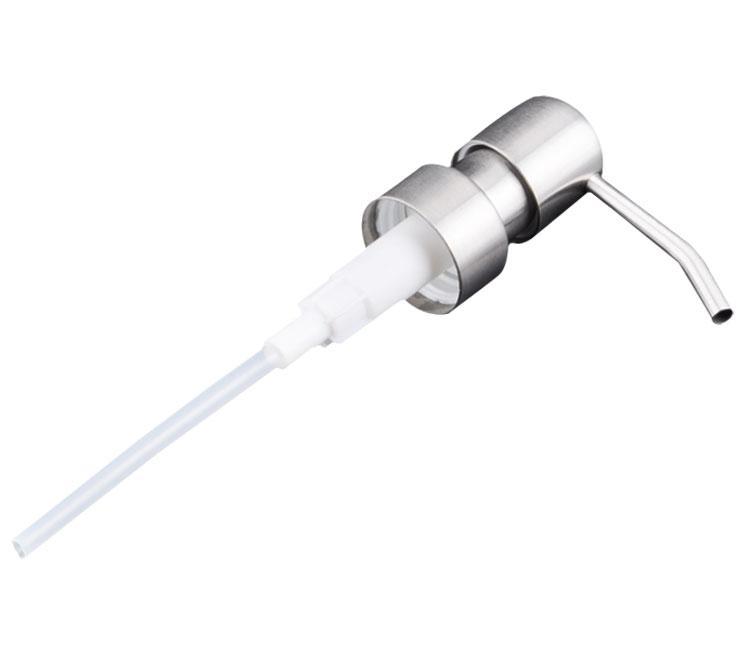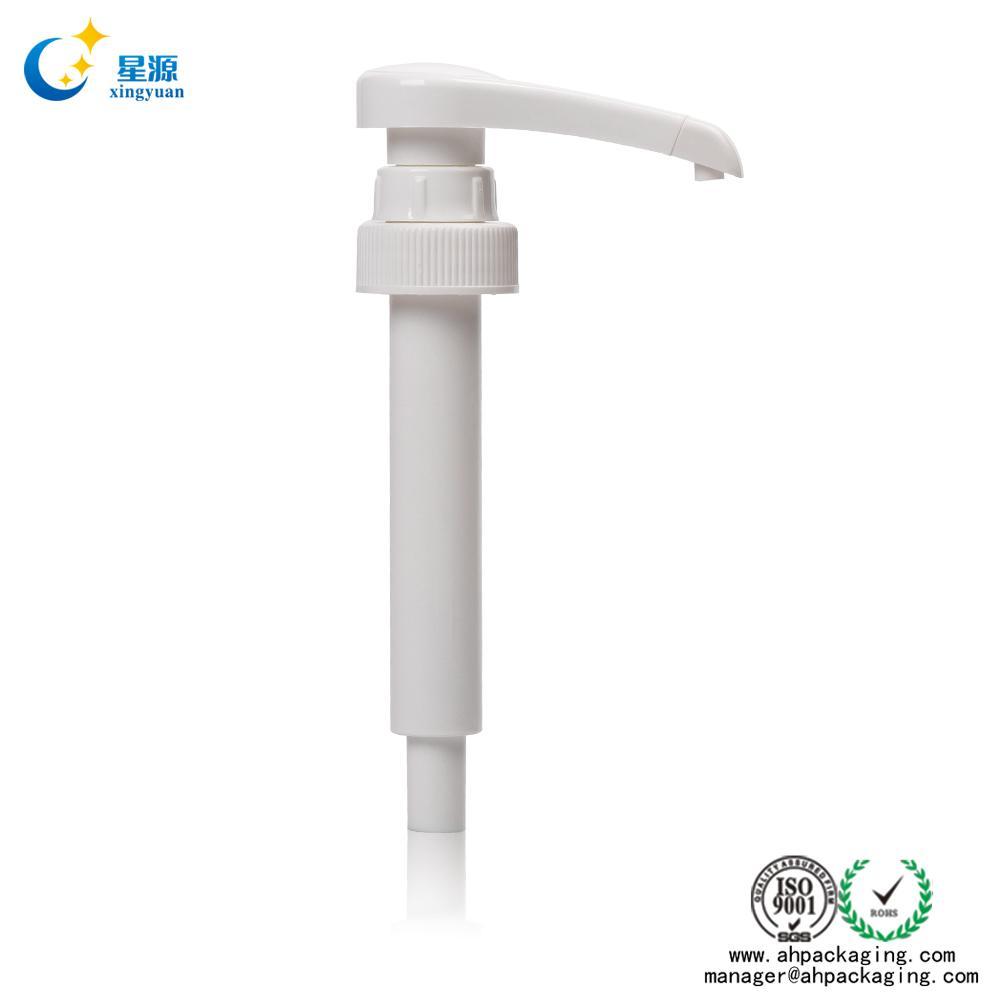The first image is the image on the left, the second image is the image on the right. Assess this claim about the two images: "The left and right image contains the same number of soap pumps.". Correct or not? Answer yes or no. Yes. The first image is the image on the left, the second image is the image on the right. Assess this claim about the two images: "The nozzle in the left image is silver colored.". Correct or not? Answer yes or no. Yes. 